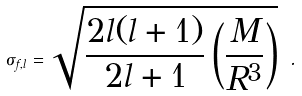<formula> <loc_0><loc_0><loc_500><loc_500>\sigma _ { f , l } = \sqrt { \frac { 2 l ( l + 1 ) } { 2 l + 1 } \left ( \frac { M } { R ^ { 3 } } \right ) } \ .</formula> 